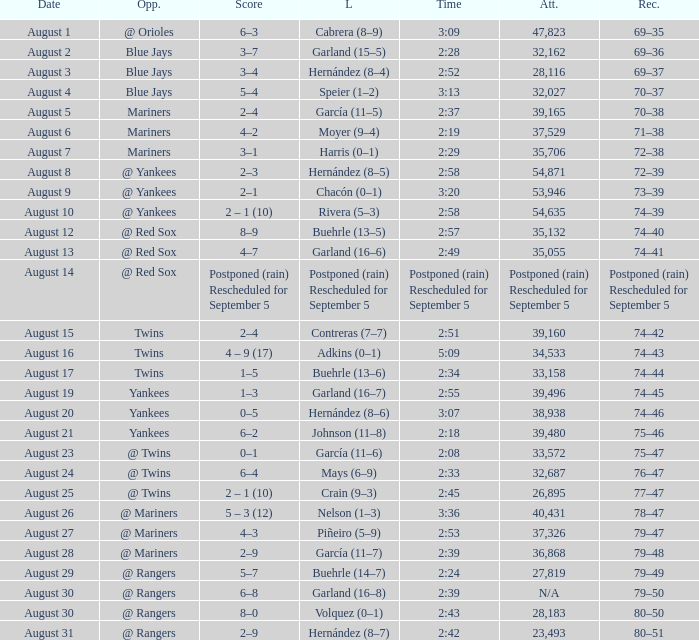Who was defeated on august 27? Piñeiro (5–9). 